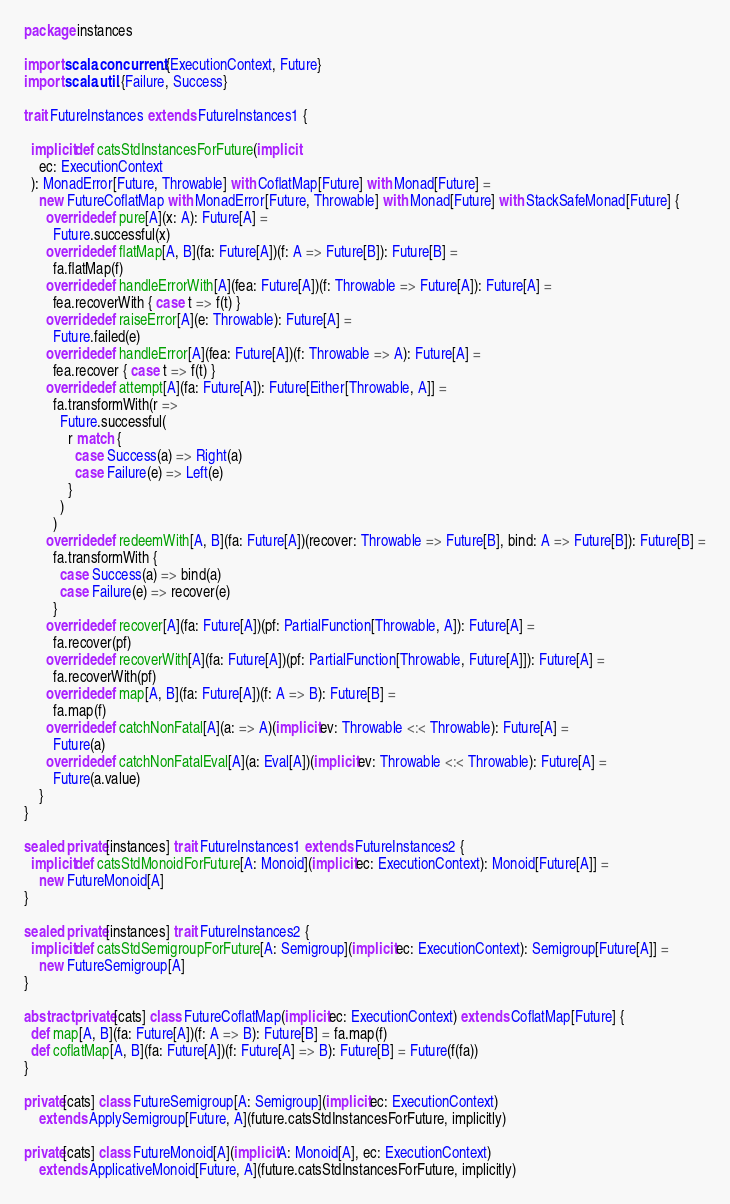Convert code to text. <code><loc_0><loc_0><loc_500><loc_500><_Scala_>package instances

import scala.concurrent.{ExecutionContext, Future}
import scala.util.{Failure, Success}

trait FutureInstances extends FutureInstances1 {

  implicit def catsStdInstancesForFuture(implicit
    ec: ExecutionContext
  ): MonadError[Future, Throwable] with CoflatMap[Future] with Monad[Future] =
    new FutureCoflatMap with MonadError[Future, Throwable] with Monad[Future] with StackSafeMonad[Future] {
      override def pure[A](x: A): Future[A] =
        Future.successful(x)
      override def flatMap[A, B](fa: Future[A])(f: A => Future[B]): Future[B] =
        fa.flatMap(f)
      override def handleErrorWith[A](fea: Future[A])(f: Throwable => Future[A]): Future[A] =
        fea.recoverWith { case t => f(t) }
      override def raiseError[A](e: Throwable): Future[A] =
        Future.failed(e)
      override def handleError[A](fea: Future[A])(f: Throwable => A): Future[A] =
        fea.recover { case t => f(t) }
      override def attempt[A](fa: Future[A]): Future[Either[Throwable, A]] =
        fa.transformWith(r =>
          Future.successful(
            r match {
              case Success(a) => Right(a)
              case Failure(e) => Left(e)
            }
          )
        )
      override def redeemWith[A, B](fa: Future[A])(recover: Throwable => Future[B], bind: A => Future[B]): Future[B] =
        fa.transformWith {
          case Success(a) => bind(a)
          case Failure(e) => recover(e)
        }
      override def recover[A](fa: Future[A])(pf: PartialFunction[Throwable, A]): Future[A] =
        fa.recover(pf)
      override def recoverWith[A](fa: Future[A])(pf: PartialFunction[Throwable, Future[A]]): Future[A] =
        fa.recoverWith(pf)
      override def map[A, B](fa: Future[A])(f: A => B): Future[B] =
        fa.map(f)
      override def catchNonFatal[A](a: => A)(implicit ev: Throwable <:< Throwable): Future[A] =
        Future(a)
      override def catchNonFatalEval[A](a: Eval[A])(implicit ev: Throwable <:< Throwable): Future[A] =
        Future(a.value)
    }
}

sealed private[instances] trait FutureInstances1 extends FutureInstances2 {
  implicit def catsStdMonoidForFuture[A: Monoid](implicit ec: ExecutionContext): Monoid[Future[A]] =
    new FutureMonoid[A]
}

sealed private[instances] trait FutureInstances2 {
  implicit def catsStdSemigroupForFuture[A: Semigroup](implicit ec: ExecutionContext): Semigroup[Future[A]] =
    new FutureSemigroup[A]
}

abstract private[cats] class FutureCoflatMap(implicit ec: ExecutionContext) extends CoflatMap[Future] {
  def map[A, B](fa: Future[A])(f: A => B): Future[B] = fa.map(f)
  def coflatMap[A, B](fa: Future[A])(f: Future[A] => B): Future[B] = Future(f(fa))
}

private[cats] class FutureSemigroup[A: Semigroup](implicit ec: ExecutionContext)
    extends ApplySemigroup[Future, A](future.catsStdInstancesForFuture, implicitly)

private[cats] class FutureMonoid[A](implicit A: Monoid[A], ec: ExecutionContext)
    extends ApplicativeMonoid[Future, A](future.catsStdInstancesForFuture, implicitly)
</code> 